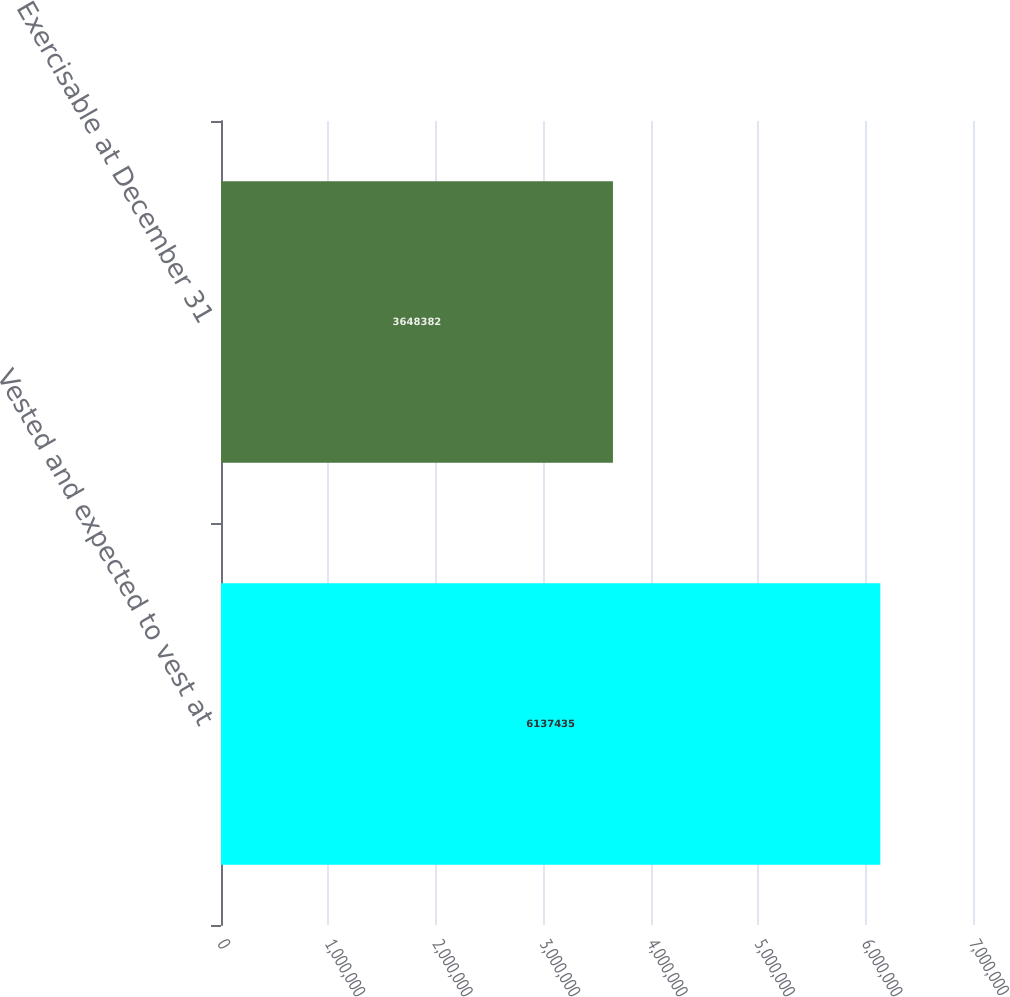Convert chart to OTSL. <chart><loc_0><loc_0><loc_500><loc_500><bar_chart><fcel>Vested and expected to vest at<fcel>Exercisable at December 31<nl><fcel>6.13744e+06<fcel>3.64838e+06<nl></chart> 